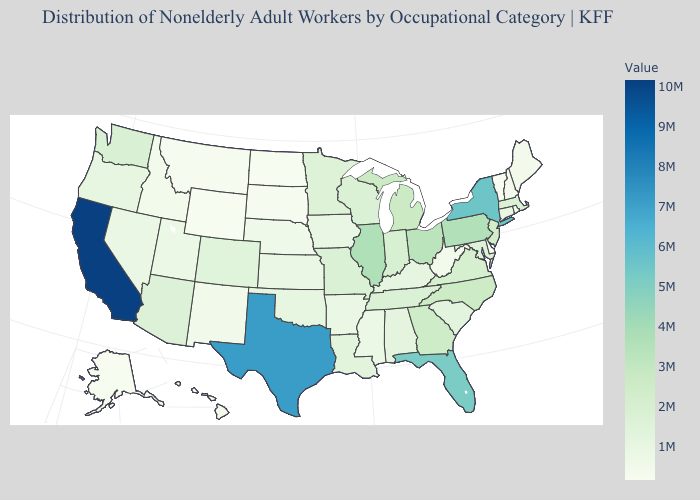Among the states that border Delaware , does Pennsylvania have the highest value?
Give a very brief answer. Yes. Does the map have missing data?
Short answer required. No. Does Texas have the highest value in the South?
Short answer required. Yes. Does Arizona have the lowest value in the USA?
Write a very short answer. No. Among the states that border Tennessee , which have the lowest value?
Answer briefly. Mississippi. Is the legend a continuous bar?
Short answer required. Yes. 